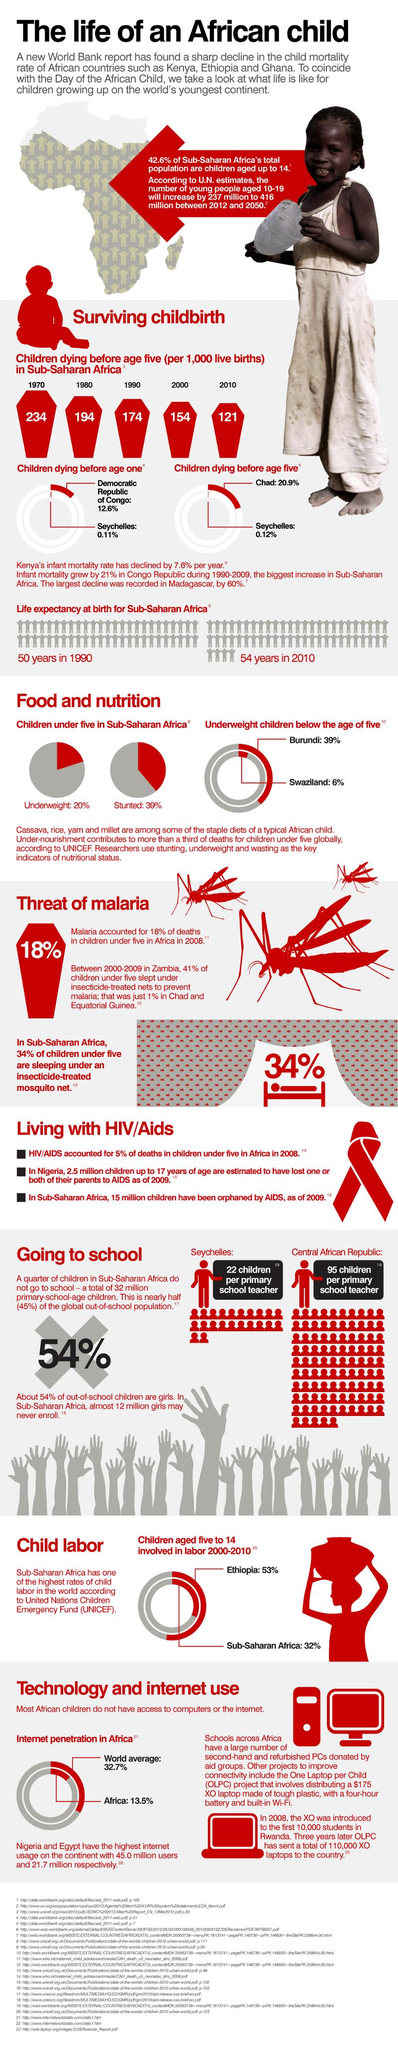Give some essential details in this illustration. The Democratic Republic of Congo had a high rate of children dying before the age of one, according to the data. According to data from 2010, life expectancy at birth had increased to an age of 54 years. According to data, approximately 57.4% of the Sub-Saharan African population is aged above 14. According to the United Nations estimates, the young population is projected to increase by 75.52% between 2012 and 2050. According to data, Ethiopia has the highest percentage of children involved in labor. 